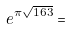<formula> <loc_0><loc_0><loc_500><loc_500>e ^ { \pi \sqrt { 1 6 3 } } =</formula> 